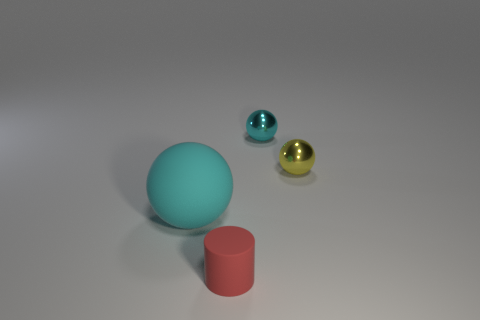Add 4 small purple metal spheres. How many objects exist? 8 Subtract all spheres. How many objects are left? 1 Add 1 tiny cyan blocks. How many tiny cyan blocks exist? 1 Subtract 0 red blocks. How many objects are left? 4 Subtract all large cyan things. Subtract all yellow balls. How many objects are left? 2 Add 1 large objects. How many large objects are left? 2 